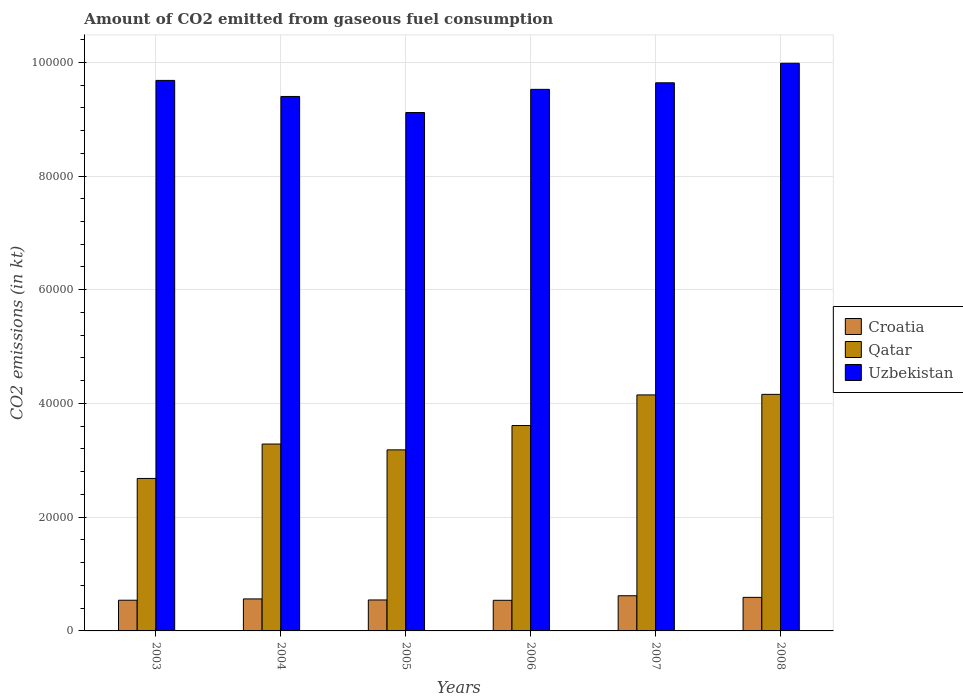How many groups of bars are there?
Make the answer very short. 6. Are the number of bars on each tick of the X-axis equal?
Give a very brief answer. Yes. How many bars are there on the 5th tick from the right?
Offer a very short reply. 3. What is the amount of CO2 emitted in Uzbekistan in 2006?
Give a very brief answer. 9.52e+04. Across all years, what is the maximum amount of CO2 emitted in Qatar?
Your response must be concise. 4.16e+04. Across all years, what is the minimum amount of CO2 emitted in Uzbekistan?
Your response must be concise. 9.12e+04. In which year was the amount of CO2 emitted in Croatia minimum?
Give a very brief answer. 2006. What is the total amount of CO2 emitted in Uzbekistan in the graph?
Ensure brevity in your answer.  5.73e+05. What is the difference between the amount of CO2 emitted in Croatia in 2005 and that in 2006?
Provide a short and direct response. 62.34. What is the difference between the amount of CO2 emitted in Uzbekistan in 2007 and the amount of CO2 emitted in Qatar in 2004?
Provide a short and direct response. 6.35e+04. What is the average amount of CO2 emitted in Qatar per year?
Offer a terse response. 3.51e+04. In the year 2005, what is the difference between the amount of CO2 emitted in Croatia and amount of CO2 emitted in Qatar?
Provide a succinct answer. -2.64e+04. In how many years, is the amount of CO2 emitted in Qatar greater than 68000 kt?
Provide a succinct answer. 0. What is the ratio of the amount of CO2 emitted in Uzbekistan in 2003 to that in 2004?
Provide a succinct answer. 1.03. Is the amount of CO2 emitted in Uzbekistan in 2004 less than that in 2008?
Keep it short and to the point. Yes. Is the difference between the amount of CO2 emitted in Croatia in 2004 and 2008 greater than the difference between the amount of CO2 emitted in Qatar in 2004 and 2008?
Offer a very short reply. Yes. What is the difference between the highest and the second highest amount of CO2 emitted in Qatar?
Your answer should be compact. 95.34. What is the difference between the highest and the lowest amount of CO2 emitted in Qatar?
Give a very brief answer. 1.48e+04. In how many years, is the amount of CO2 emitted in Qatar greater than the average amount of CO2 emitted in Qatar taken over all years?
Keep it short and to the point. 3. Is the sum of the amount of CO2 emitted in Croatia in 2003 and 2008 greater than the maximum amount of CO2 emitted in Uzbekistan across all years?
Your response must be concise. No. What does the 2nd bar from the left in 2007 represents?
Your response must be concise. Qatar. What does the 1st bar from the right in 2003 represents?
Provide a succinct answer. Uzbekistan. Is it the case that in every year, the sum of the amount of CO2 emitted in Croatia and amount of CO2 emitted in Qatar is greater than the amount of CO2 emitted in Uzbekistan?
Make the answer very short. No. How many bars are there?
Your answer should be very brief. 18. Are all the bars in the graph horizontal?
Offer a terse response. No. How many years are there in the graph?
Your answer should be very brief. 6. What is the difference between two consecutive major ticks on the Y-axis?
Keep it short and to the point. 2.00e+04. Are the values on the major ticks of Y-axis written in scientific E-notation?
Keep it short and to the point. No. Does the graph contain any zero values?
Provide a succinct answer. No. Does the graph contain grids?
Give a very brief answer. Yes. How many legend labels are there?
Offer a terse response. 3. What is the title of the graph?
Provide a succinct answer. Amount of CO2 emitted from gaseous fuel consumption. What is the label or title of the Y-axis?
Your answer should be very brief. CO2 emissions (in kt). What is the CO2 emissions (in kt) of Croatia in 2003?
Keep it short and to the point. 5397.82. What is the CO2 emissions (in kt) in Qatar in 2003?
Offer a terse response. 2.68e+04. What is the CO2 emissions (in kt) of Uzbekistan in 2003?
Give a very brief answer. 9.68e+04. What is the CO2 emissions (in kt) of Croatia in 2004?
Make the answer very short. 5628.85. What is the CO2 emissions (in kt) of Qatar in 2004?
Offer a terse response. 3.29e+04. What is the CO2 emissions (in kt) of Uzbekistan in 2004?
Your answer should be compact. 9.40e+04. What is the CO2 emissions (in kt) of Croatia in 2005?
Provide a short and direct response. 5445.49. What is the CO2 emissions (in kt) in Qatar in 2005?
Offer a very short reply. 3.18e+04. What is the CO2 emissions (in kt) of Uzbekistan in 2005?
Your response must be concise. 9.12e+04. What is the CO2 emissions (in kt) in Croatia in 2006?
Your answer should be compact. 5383.16. What is the CO2 emissions (in kt) of Qatar in 2006?
Ensure brevity in your answer.  3.61e+04. What is the CO2 emissions (in kt) in Uzbekistan in 2006?
Give a very brief answer. 9.52e+04. What is the CO2 emissions (in kt) in Croatia in 2007?
Keep it short and to the point. 6186.23. What is the CO2 emissions (in kt) of Qatar in 2007?
Ensure brevity in your answer.  4.15e+04. What is the CO2 emissions (in kt) in Uzbekistan in 2007?
Ensure brevity in your answer.  9.64e+04. What is the CO2 emissions (in kt) in Croatia in 2008?
Your answer should be compact. 5900.2. What is the CO2 emissions (in kt) of Qatar in 2008?
Make the answer very short. 4.16e+04. What is the CO2 emissions (in kt) of Uzbekistan in 2008?
Give a very brief answer. 9.98e+04. Across all years, what is the maximum CO2 emissions (in kt) in Croatia?
Offer a very short reply. 6186.23. Across all years, what is the maximum CO2 emissions (in kt) of Qatar?
Your answer should be compact. 4.16e+04. Across all years, what is the maximum CO2 emissions (in kt) of Uzbekistan?
Your answer should be very brief. 9.98e+04. Across all years, what is the minimum CO2 emissions (in kt) in Croatia?
Keep it short and to the point. 5383.16. Across all years, what is the minimum CO2 emissions (in kt) in Qatar?
Make the answer very short. 2.68e+04. Across all years, what is the minimum CO2 emissions (in kt) of Uzbekistan?
Provide a short and direct response. 9.12e+04. What is the total CO2 emissions (in kt) in Croatia in the graph?
Your response must be concise. 3.39e+04. What is the total CO2 emissions (in kt) in Qatar in the graph?
Keep it short and to the point. 2.11e+05. What is the total CO2 emissions (in kt) of Uzbekistan in the graph?
Make the answer very short. 5.73e+05. What is the difference between the CO2 emissions (in kt) in Croatia in 2003 and that in 2004?
Your answer should be very brief. -231.02. What is the difference between the CO2 emissions (in kt) in Qatar in 2003 and that in 2004?
Ensure brevity in your answer.  -6050.55. What is the difference between the CO2 emissions (in kt) in Uzbekistan in 2003 and that in 2004?
Provide a short and direct response. 2823.59. What is the difference between the CO2 emissions (in kt) of Croatia in 2003 and that in 2005?
Ensure brevity in your answer.  -47.67. What is the difference between the CO2 emissions (in kt) in Qatar in 2003 and that in 2005?
Provide a succinct answer. -5027.46. What is the difference between the CO2 emissions (in kt) in Uzbekistan in 2003 and that in 2005?
Your answer should be compact. 5650.85. What is the difference between the CO2 emissions (in kt) of Croatia in 2003 and that in 2006?
Your answer should be very brief. 14.67. What is the difference between the CO2 emissions (in kt) of Qatar in 2003 and that in 2006?
Your answer should be very brief. -9303.18. What is the difference between the CO2 emissions (in kt) of Uzbekistan in 2003 and that in 2006?
Keep it short and to the point. 1573.14. What is the difference between the CO2 emissions (in kt) in Croatia in 2003 and that in 2007?
Your response must be concise. -788.4. What is the difference between the CO2 emissions (in kt) of Qatar in 2003 and that in 2007?
Offer a terse response. -1.47e+04. What is the difference between the CO2 emissions (in kt) in Uzbekistan in 2003 and that in 2007?
Provide a succinct answer. 421.7. What is the difference between the CO2 emissions (in kt) of Croatia in 2003 and that in 2008?
Your answer should be compact. -502.38. What is the difference between the CO2 emissions (in kt) in Qatar in 2003 and that in 2008?
Make the answer very short. -1.48e+04. What is the difference between the CO2 emissions (in kt) in Uzbekistan in 2003 and that in 2008?
Your answer should be compact. -3014.27. What is the difference between the CO2 emissions (in kt) of Croatia in 2004 and that in 2005?
Make the answer very short. 183.35. What is the difference between the CO2 emissions (in kt) in Qatar in 2004 and that in 2005?
Give a very brief answer. 1023.09. What is the difference between the CO2 emissions (in kt) of Uzbekistan in 2004 and that in 2005?
Provide a short and direct response. 2827.26. What is the difference between the CO2 emissions (in kt) of Croatia in 2004 and that in 2006?
Make the answer very short. 245.69. What is the difference between the CO2 emissions (in kt) in Qatar in 2004 and that in 2006?
Give a very brief answer. -3252.63. What is the difference between the CO2 emissions (in kt) of Uzbekistan in 2004 and that in 2006?
Ensure brevity in your answer.  -1250.45. What is the difference between the CO2 emissions (in kt) in Croatia in 2004 and that in 2007?
Your response must be concise. -557.38. What is the difference between the CO2 emissions (in kt) in Qatar in 2004 and that in 2007?
Give a very brief answer. -8639.45. What is the difference between the CO2 emissions (in kt) of Uzbekistan in 2004 and that in 2007?
Provide a short and direct response. -2401.89. What is the difference between the CO2 emissions (in kt) in Croatia in 2004 and that in 2008?
Provide a succinct answer. -271.36. What is the difference between the CO2 emissions (in kt) of Qatar in 2004 and that in 2008?
Your response must be concise. -8734.79. What is the difference between the CO2 emissions (in kt) of Uzbekistan in 2004 and that in 2008?
Give a very brief answer. -5837.86. What is the difference between the CO2 emissions (in kt) in Croatia in 2005 and that in 2006?
Give a very brief answer. 62.34. What is the difference between the CO2 emissions (in kt) of Qatar in 2005 and that in 2006?
Keep it short and to the point. -4275.72. What is the difference between the CO2 emissions (in kt) of Uzbekistan in 2005 and that in 2006?
Provide a short and direct response. -4077.7. What is the difference between the CO2 emissions (in kt) of Croatia in 2005 and that in 2007?
Offer a terse response. -740.73. What is the difference between the CO2 emissions (in kt) in Qatar in 2005 and that in 2007?
Keep it short and to the point. -9662.55. What is the difference between the CO2 emissions (in kt) of Uzbekistan in 2005 and that in 2007?
Ensure brevity in your answer.  -5229.14. What is the difference between the CO2 emissions (in kt) of Croatia in 2005 and that in 2008?
Give a very brief answer. -454.71. What is the difference between the CO2 emissions (in kt) in Qatar in 2005 and that in 2008?
Offer a terse response. -9757.89. What is the difference between the CO2 emissions (in kt) in Uzbekistan in 2005 and that in 2008?
Your answer should be very brief. -8665.12. What is the difference between the CO2 emissions (in kt) of Croatia in 2006 and that in 2007?
Offer a very short reply. -803.07. What is the difference between the CO2 emissions (in kt) in Qatar in 2006 and that in 2007?
Provide a succinct answer. -5386.82. What is the difference between the CO2 emissions (in kt) of Uzbekistan in 2006 and that in 2007?
Provide a succinct answer. -1151.44. What is the difference between the CO2 emissions (in kt) in Croatia in 2006 and that in 2008?
Ensure brevity in your answer.  -517.05. What is the difference between the CO2 emissions (in kt) of Qatar in 2006 and that in 2008?
Your answer should be very brief. -5482.16. What is the difference between the CO2 emissions (in kt) of Uzbekistan in 2006 and that in 2008?
Keep it short and to the point. -4587.42. What is the difference between the CO2 emissions (in kt) in Croatia in 2007 and that in 2008?
Keep it short and to the point. 286.03. What is the difference between the CO2 emissions (in kt) in Qatar in 2007 and that in 2008?
Give a very brief answer. -95.34. What is the difference between the CO2 emissions (in kt) in Uzbekistan in 2007 and that in 2008?
Provide a short and direct response. -3435.98. What is the difference between the CO2 emissions (in kt) in Croatia in 2003 and the CO2 emissions (in kt) in Qatar in 2004?
Provide a short and direct response. -2.75e+04. What is the difference between the CO2 emissions (in kt) in Croatia in 2003 and the CO2 emissions (in kt) in Uzbekistan in 2004?
Give a very brief answer. -8.86e+04. What is the difference between the CO2 emissions (in kt) of Qatar in 2003 and the CO2 emissions (in kt) of Uzbekistan in 2004?
Your answer should be very brief. -6.72e+04. What is the difference between the CO2 emissions (in kt) of Croatia in 2003 and the CO2 emissions (in kt) of Qatar in 2005?
Your answer should be very brief. -2.64e+04. What is the difference between the CO2 emissions (in kt) in Croatia in 2003 and the CO2 emissions (in kt) in Uzbekistan in 2005?
Your answer should be very brief. -8.58e+04. What is the difference between the CO2 emissions (in kt) in Qatar in 2003 and the CO2 emissions (in kt) in Uzbekistan in 2005?
Make the answer very short. -6.43e+04. What is the difference between the CO2 emissions (in kt) in Croatia in 2003 and the CO2 emissions (in kt) in Qatar in 2006?
Give a very brief answer. -3.07e+04. What is the difference between the CO2 emissions (in kt) of Croatia in 2003 and the CO2 emissions (in kt) of Uzbekistan in 2006?
Your answer should be compact. -8.98e+04. What is the difference between the CO2 emissions (in kt) of Qatar in 2003 and the CO2 emissions (in kt) of Uzbekistan in 2006?
Offer a terse response. -6.84e+04. What is the difference between the CO2 emissions (in kt) of Croatia in 2003 and the CO2 emissions (in kt) of Qatar in 2007?
Give a very brief answer. -3.61e+04. What is the difference between the CO2 emissions (in kt) of Croatia in 2003 and the CO2 emissions (in kt) of Uzbekistan in 2007?
Give a very brief answer. -9.10e+04. What is the difference between the CO2 emissions (in kt) in Qatar in 2003 and the CO2 emissions (in kt) in Uzbekistan in 2007?
Give a very brief answer. -6.96e+04. What is the difference between the CO2 emissions (in kt) of Croatia in 2003 and the CO2 emissions (in kt) of Qatar in 2008?
Give a very brief answer. -3.62e+04. What is the difference between the CO2 emissions (in kt) of Croatia in 2003 and the CO2 emissions (in kt) of Uzbekistan in 2008?
Offer a terse response. -9.44e+04. What is the difference between the CO2 emissions (in kt) of Qatar in 2003 and the CO2 emissions (in kt) of Uzbekistan in 2008?
Your answer should be compact. -7.30e+04. What is the difference between the CO2 emissions (in kt) in Croatia in 2004 and the CO2 emissions (in kt) in Qatar in 2005?
Ensure brevity in your answer.  -2.62e+04. What is the difference between the CO2 emissions (in kt) in Croatia in 2004 and the CO2 emissions (in kt) in Uzbekistan in 2005?
Offer a terse response. -8.55e+04. What is the difference between the CO2 emissions (in kt) in Qatar in 2004 and the CO2 emissions (in kt) in Uzbekistan in 2005?
Provide a short and direct response. -5.83e+04. What is the difference between the CO2 emissions (in kt) of Croatia in 2004 and the CO2 emissions (in kt) of Qatar in 2006?
Your answer should be very brief. -3.05e+04. What is the difference between the CO2 emissions (in kt) of Croatia in 2004 and the CO2 emissions (in kt) of Uzbekistan in 2006?
Provide a succinct answer. -8.96e+04. What is the difference between the CO2 emissions (in kt) in Qatar in 2004 and the CO2 emissions (in kt) in Uzbekistan in 2006?
Your answer should be compact. -6.24e+04. What is the difference between the CO2 emissions (in kt) in Croatia in 2004 and the CO2 emissions (in kt) in Qatar in 2007?
Your response must be concise. -3.59e+04. What is the difference between the CO2 emissions (in kt) of Croatia in 2004 and the CO2 emissions (in kt) of Uzbekistan in 2007?
Ensure brevity in your answer.  -9.08e+04. What is the difference between the CO2 emissions (in kt) of Qatar in 2004 and the CO2 emissions (in kt) of Uzbekistan in 2007?
Offer a terse response. -6.35e+04. What is the difference between the CO2 emissions (in kt) of Croatia in 2004 and the CO2 emissions (in kt) of Qatar in 2008?
Keep it short and to the point. -3.60e+04. What is the difference between the CO2 emissions (in kt) in Croatia in 2004 and the CO2 emissions (in kt) in Uzbekistan in 2008?
Provide a short and direct response. -9.42e+04. What is the difference between the CO2 emissions (in kt) in Qatar in 2004 and the CO2 emissions (in kt) in Uzbekistan in 2008?
Keep it short and to the point. -6.70e+04. What is the difference between the CO2 emissions (in kt) of Croatia in 2005 and the CO2 emissions (in kt) of Qatar in 2006?
Offer a terse response. -3.07e+04. What is the difference between the CO2 emissions (in kt) of Croatia in 2005 and the CO2 emissions (in kt) of Uzbekistan in 2006?
Ensure brevity in your answer.  -8.98e+04. What is the difference between the CO2 emissions (in kt) in Qatar in 2005 and the CO2 emissions (in kt) in Uzbekistan in 2006?
Offer a very short reply. -6.34e+04. What is the difference between the CO2 emissions (in kt) in Croatia in 2005 and the CO2 emissions (in kt) in Qatar in 2007?
Offer a terse response. -3.61e+04. What is the difference between the CO2 emissions (in kt) of Croatia in 2005 and the CO2 emissions (in kt) of Uzbekistan in 2007?
Provide a short and direct response. -9.09e+04. What is the difference between the CO2 emissions (in kt) of Qatar in 2005 and the CO2 emissions (in kt) of Uzbekistan in 2007?
Your answer should be very brief. -6.46e+04. What is the difference between the CO2 emissions (in kt) in Croatia in 2005 and the CO2 emissions (in kt) in Qatar in 2008?
Provide a short and direct response. -3.62e+04. What is the difference between the CO2 emissions (in kt) of Croatia in 2005 and the CO2 emissions (in kt) of Uzbekistan in 2008?
Your answer should be very brief. -9.44e+04. What is the difference between the CO2 emissions (in kt) in Qatar in 2005 and the CO2 emissions (in kt) in Uzbekistan in 2008?
Give a very brief answer. -6.80e+04. What is the difference between the CO2 emissions (in kt) in Croatia in 2006 and the CO2 emissions (in kt) in Qatar in 2007?
Your answer should be compact. -3.61e+04. What is the difference between the CO2 emissions (in kt) in Croatia in 2006 and the CO2 emissions (in kt) in Uzbekistan in 2007?
Provide a succinct answer. -9.10e+04. What is the difference between the CO2 emissions (in kt) of Qatar in 2006 and the CO2 emissions (in kt) of Uzbekistan in 2007?
Give a very brief answer. -6.03e+04. What is the difference between the CO2 emissions (in kt) of Croatia in 2006 and the CO2 emissions (in kt) of Qatar in 2008?
Your answer should be very brief. -3.62e+04. What is the difference between the CO2 emissions (in kt) in Croatia in 2006 and the CO2 emissions (in kt) in Uzbekistan in 2008?
Ensure brevity in your answer.  -9.44e+04. What is the difference between the CO2 emissions (in kt) of Qatar in 2006 and the CO2 emissions (in kt) of Uzbekistan in 2008?
Keep it short and to the point. -6.37e+04. What is the difference between the CO2 emissions (in kt) of Croatia in 2007 and the CO2 emissions (in kt) of Qatar in 2008?
Keep it short and to the point. -3.54e+04. What is the difference between the CO2 emissions (in kt) in Croatia in 2007 and the CO2 emissions (in kt) in Uzbekistan in 2008?
Give a very brief answer. -9.36e+04. What is the difference between the CO2 emissions (in kt) of Qatar in 2007 and the CO2 emissions (in kt) of Uzbekistan in 2008?
Make the answer very short. -5.83e+04. What is the average CO2 emissions (in kt) of Croatia per year?
Ensure brevity in your answer.  5656.96. What is the average CO2 emissions (in kt) in Qatar per year?
Keep it short and to the point. 3.51e+04. What is the average CO2 emissions (in kt) of Uzbekistan per year?
Make the answer very short. 9.56e+04. In the year 2003, what is the difference between the CO2 emissions (in kt) of Croatia and CO2 emissions (in kt) of Qatar?
Your answer should be very brief. -2.14e+04. In the year 2003, what is the difference between the CO2 emissions (in kt) of Croatia and CO2 emissions (in kt) of Uzbekistan?
Ensure brevity in your answer.  -9.14e+04. In the year 2003, what is the difference between the CO2 emissions (in kt) of Qatar and CO2 emissions (in kt) of Uzbekistan?
Keep it short and to the point. -7.00e+04. In the year 2004, what is the difference between the CO2 emissions (in kt) in Croatia and CO2 emissions (in kt) in Qatar?
Provide a succinct answer. -2.72e+04. In the year 2004, what is the difference between the CO2 emissions (in kt) in Croatia and CO2 emissions (in kt) in Uzbekistan?
Keep it short and to the point. -8.84e+04. In the year 2004, what is the difference between the CO2 emissions (in kt) in Qatar and CO2 emissions (in kt) in Uzbekistan?
Your answer should be compact. -6.11e+04. In the year 2005, what is the difference between the CO2 emissions (in kt) of Croatia and CO2 emissions (in kt) of Qatar?
Your answer should be very brief. -2.64e+04. In the year 2005, what is the difference between the CO2 emissions (in kt) in Croatia and CO2 emissions (in kt) in Uzbekistan?
Your answer should be very brief. -8.57e+04. In the year 2005, what is the difference between the CO2 emissions (in kt) of Qatar and CO2 emissions (in kt) of Uzbekistan?
Keep it short and to the point. -5.93e+04. In the year 2006, what is the difference between the CO2 emissions (in kt) of Croatia and CO2 emissions (in kt) of Qatar?
Give a very brief answer. -3.07e+04. In the year 2006, what is the difference between the CO2 emissions (in kt) in Croatia and CO2 emissions (in kt) in Uzbekistan?
Offer a very short reply. -8.99e+04. In the year 2006, what is the difference between the CO2 emissions (in kt) of Qatar and CO2 emissions (in kt) of Uzbekistan?
Provide a short and direct response. -5.91e+04. In the year 2007, what is the difference between the CO2 emissions (in kt) in Croatia and CO2 emissions (in kt) in Qatar?
Give a very brief answer. -3.53e+04. In the year 2007, what is the difference between the CO2 emissions (in kt) in Croatia and CO2 emissions (in kt) in Uzbekistan?
Your response must be concise. -9.02e+04. In the year 2007, what is the difference between the CO2 emissions (in kt) in Qatar and CO2 emissions (in kt) in Uzbekistan?
Offer a very short reply. -5.49e+04. In the year 2008, what is the difference between the CO2 emissions (in kt) in Croatia and CO2 emissions (in kt) in Qatar?
Your response must be concise. -3.57e+04. In the year 2008, what is the difference between the CO2 emissions (in kt) of Croatia and CO2 emissions (in kt) of Uzbekistan?
Provide a short and direct response. -9.39e+04. In the year 2008, what is the difference between the CO2 emissions (in kt) of Qatar and CO2 emissions (in kt) of Uzbekistan?
Give a very brief answer. -5.82e+04. What is the ratio of the CO2 emissions (in kt) of Croatia in 2003 to that in 2004?
Keep it short and to the point. 0.96. What is the ratio of the CO2 emissions (in kt) in Qatar in 2003 to that in 2004?
Give a very brief answer. 0.82. What is the ratio of the CO2 emissions (in kt) of Uzbekistan in 2003 to that in 2004?
Offer a very short reply. 1.03. What is the ratio of the CO2 emissions (in kt) in Qatar in 2003 to that in 2005?
Keep it short and to the point. 0.84. What is the ratio of the CO2 emissions (in kt) in Uzbekistan in 2003 to that in 2005?
Offer a terse response. 1.06. What is the ratio of the CO2 emissions (in kt) of Croatia in 2003 to that in 2006?
Your response must be concise. 1. What is the ratio of the CO2 emissions (in kt) in Qatar in 2003 to that in 2006?
Your response must be concise. 0.74. What is the ratio of the CO2 emissions (in kt) in Uzbekistan in 2003 to that in 2006?
Offer a terse response. 1.02. What is the ratio of the CO2 emissions (in kt) in Croatia in 2003 to that in 2007?
Make the answer very short. 0.87. What is the ratio of the CO2 emissions (in kt) of Qatar in 2003 to that in 2007?
Offer a very short reply. 0.65. What is the ratio of the CO2 emissions (in kt) of Croatia in 2003 to that in 2008?
Make the answer very short. 0.91. What is the ratio of the CO2 emissions (in kt) in Qatar in 2003 to that in 2008?
Your answer should be compact. 0.64. What is the ratio of the CO2 emissions (in kt) in Uzbekistan in 2003 to that in 2008?
Your response must be concise. 0.97. What is the ratio of the CO2 emissions (in kt) of Croatia in 2004 to that in 2005?
Your answer should be compact. 1.03. What is the ratio of the CO2 emissions (in kt) of Qatar in 2004 to that in 2005?
Your response must be concise. 1.03. What is the ratio of the CO2 emissions (in kt) in Uzbekistan in 2004 to that in 2005?
Provide a short and direct response. 1.03. What is the ratio of the CO2 emissions (in kt) of Croatia in 2004 to that in 2006?
Provide a short and direct response. 1.05. What is the ratio of the CO2 emissions (in kt) of Qatar in 2004 to that in 2006?
Make the answer very short. 0.91. What is the ratio of the CO2 emissions (in kt) in Uzbekistan in 2004 to that in 2006?
Your response must be concise. 0.99. What is the ratio of the CO2 emissions (in kt) of Croatia in 2004 to that in 2007?
Provide a succinct answer. 0.91. What is the ratio of the CO2 emissions (in kt) in Qatar in 2004 to that in 2007?
Give a very brief answer. 0.79. What is the ratio of the CO2 emissions (in kt) in Uzbekistan in 2004 to that in 2007?
Keep it short and to the point. 0.98. What is the ratio of the CO2 emissions (in kt) in Croatia in 2004 to that in 2008?
Ensure brevity in your answer.  0.95. What is the ratio of the CO2 emissions (in kt) in Qatar in 2004 to that in 2008?
Your answer should be compact. 0.79. What is the ratio of the CO2 emissions (in kt) of Uzbekistan in 2004 to that in 2008?
Your answer should be compact. 0.94. What is the ratio of the CO2 emissions (in kt) in Croatia in 2005 to that in 2006?
Keep it short and to the point. 1.01. What is the ratio of the CO2 emissions (in kt) in Qatar in 2005 to that in 2006?
Your answer should be compact. 0.88. What is the ratio of the CO2 emissions (in kt) in Uzbekistan in 2005 to that in 2006?
Offer a very short reply. 0.96. What is the ratio of the CO2 emissions (in kt) in Croatia in 2005 to that in 2007?
Keep it short and to the point. 0.88. What is the ratio of the CO2 emissions (in kt) in Qatar in 2005 to that in 2007?
Ensure brevity in your answer.  0.77. What is the ratio of the CO2 emissions (in kt) of Uzbekistan in 2005 to that in 2007?
Your answer should be very brief. 0.95. What is the ratio of the CO2 emissions (in kt) of Croatia in 2005 to that in 2008?
Keep it short and to the point. 0.92. What is the ratio of the CO2 emissions (in kt) in Qatar in 2005 to that in 2008?
Provide a succinct answer. 0.77. What is the ratio of the CO2 emissions (in kt) in Uzbekistan in 2005 to that in 2008?
Your answer should be very brief. 0.91. What is the ratio of the CO2 emissions (in kt) in Croatia in 2006 to that in 2007?
Provide a succinct answer. 0.87. What is the ratio of the CO2 emissions (in kt) of Qatar in 2006 to that in 2007?
Give a very brief answer. 0.87. What is the ratio of the CO2 emissions (in kt) of Croatia in 2006 to that in 2008?
Offer a terse response. 0.91. What is the ratio of the CO2 emissions (in kt) of Qatar in 2006 to that in 2008?
Provide a short and direct response. 0.87. What is the ratio of the CO2 emissions (in kt) in Uzbekistan in 2006 to that in 2008?
Offer a terse response. 0.95. What is the ratio of the CO2 emissions (in kt) in Croatia in 2007 to that in 2008?
Make the answer very short. 1.05. What is the ratio of the CO2 emissions (in kt) in Uzbekistan in 2007 to that in 2008?
Ensure brevity in your answer.  0.97. What is the difference between the highest and the second highest CO2 emissions (in kt) in Croatia?
Your response must be concise. 286.03. What is the difference between the highest and the second highest CO2 emissions (in kt) of Qatar?
Your answer should be compact. 95.34. What is the difference between the highest and the second highest CO2 emissions (in kt) in Uzbekistan?
Your answer should be very brief. 3014.27. What is the difference between the highest and the lowest CO2 emissions (in kt) in Croatia?
Provide a short and direct response. 803.07. What is the difference between the highest and the lowest CO2 emissions (in kt) in Qatar?
Your response must be concise. 1.48e+04. What is the difference between the highest and the lowest CO2 emissions (in kt) in Uzbekistan?
Ensure brevity in your answer.  8665.12. 